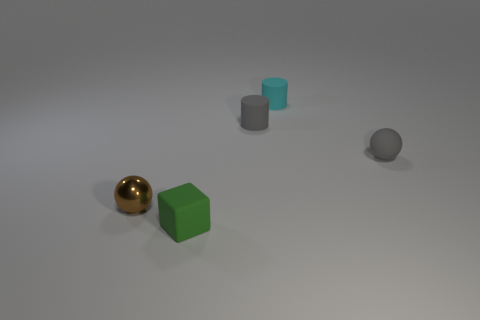Add 1 big brown things. How many objects exist? 6 Subtract all balls. How many objects are left? 3 Add 3 small purple spheres. How many small purple spheres exist? 3 Subtract 0 red cylinders. How many objects are left? 5 Subtract all small gray rubber objects. Subtract all tiny brown objects. How many objects are left? 2 Add 4 cylinders. How many cylinders are left? 6 